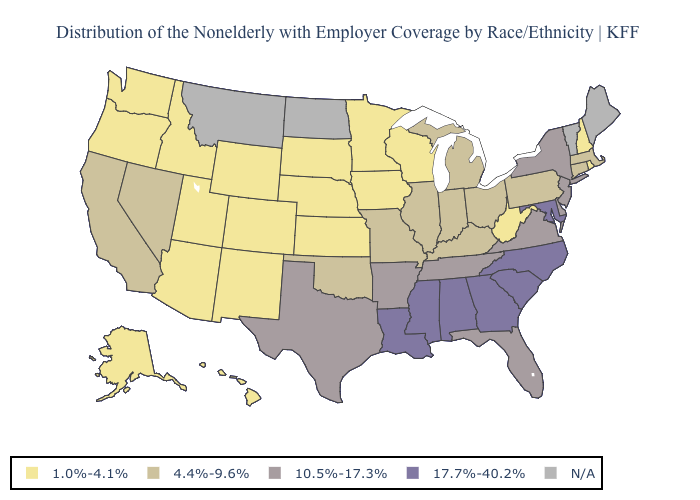What is the value of Oregon?
Write a very short answer. 1.0%-4.1%. Which states have the lowest value in the West?
Give a very brief answer. Alaska, Arizona, Colorado, Hawaii, Idaho, New Mexico, Oregon, Utah, Washington, Wyoming. Name the states that have a value in the range 1.0%-4.1%?
Concise answer only. Alaska, Arizona, Colorado, Hawaii, Idaho, Iowa, Kansas, Minnesota, Nebraska, New Hampshire, New Mexico, Oregon, Rhode Island, South Dakota, Utah, Washington, West Virginia, Wisconsin, Wyoming. Name the states that have a value in the range 1.0%-4.1%?
Answer briefly. Alaska, Arizona, Colorado, Hawaii, Idaho, Iowa, Kansas, Minnesota, Nebraska, New Hampshire, New Mexico, Oregon, Rhode Island, South Dakota, Utah, Washington, West Virginia, Wisconsin, Wyoming. Among the states that border Tennessee , which have the highest value?
Concise answer only. Alabama, Georgia, Mississippi, North Carolina. Does Arkansas have the lowest value in the USA?
Keep it brief. No. Among the states that border Vermont , which have the highest value?
Write a very short answer. New York. Name the states that have a value in the range 4.4%-9.6%?
Quick response, please. California, Connecticut, Illinois, Indiana, Kentucky, Massachusetts, Michigan, Missouri, Nevada, Ohio, Oklahoma, Pennsylvania. Is the legend a continuous bar?
Concise answer only. No. What is the lowest value in states that border Maryland?
Give a very brief answer. 1.0%-4.1%. Name the states that have a value in the range 17.7%-40.2%?
Give a very brief answer. Alabama, Georgia, Louisiana, Maryland, Mississippi, North Carolina, South Carolina. Name the states that have a value in the range N/A?
Answer briefly. Maine, Montana, North Dakota, Vermont. Which states hav the highest value in the South?
Give a very brief answer. Alabama, Georgia, Louisiana, Maryland, Mississippi, North Carolina, South Carolina. Does Idaho have the lowest value in the West?
Short answer required. Yes. Which states have the lowest value in the South?
Write a very short answer. West Virginia. 